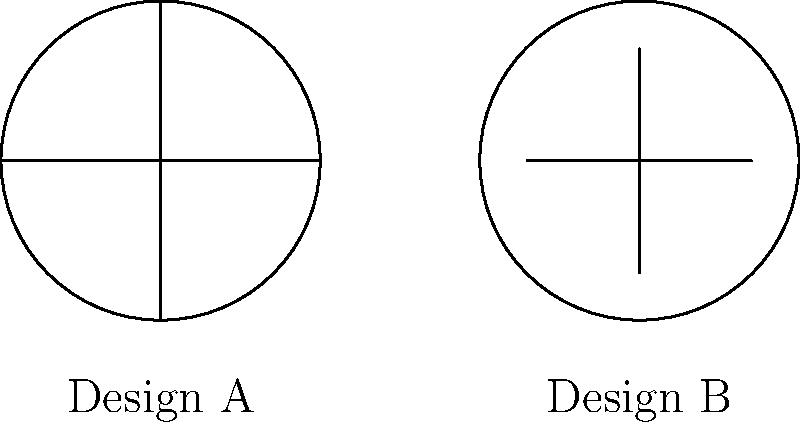Given the two design patent illustrations above, which of the following statements best describes the uniqueness of Design B compared to Design A? To assess the uniqueness of Design B compared to Design A, we need to analyze the key features and differences between the two designs:

1. Both designs are circular in shape, which is a common element.

2. Design A has two perpendicular lines that intersect at the center of the circle, creating four equal quadrants. These lines extend from edge to edge of the circle.

3. Design B also has two intersecting lines, but with notable differences:
   a. The vertical line in Design B is shorter, not extending to the edges of the circle.
   b. The horizontal line in Design B appears to be slightly shorter than the diameter of the circle.

4. The intersection point of the lines in Design B is not clearly at the center of the circle, unlike Design A where the intersection is precisely at the center.

5. In design patent law, small differences can be significant if they create a distinct overall visual impression.

6. The shortened lines and potentially off-center intersection in Design B create a visually distinct impression from Design A, despite the overall similarity in basic shape.

Given these observations, Design B exhibits unique characteristics in the arrangement and length of its internal lines, which could be considered sufficiently distinct from Design A in a design patent context.
Answer: Design B is potentially unique due to its shortened internal lines and their possibly off-center intersection. 